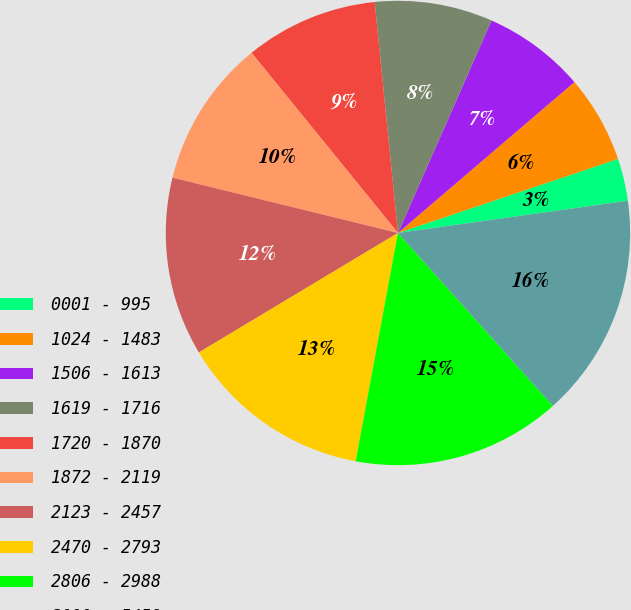<chart> <loc_0><loc_0><loc_500><loc_500><pie_chart><fcel>0001 - 995<fcel>1024 - 1483<fcel>1506 - 1613<fcel>1619 - 1716<fcel>1720 - 1870<fcel>1872 - 2119<fcel>2123 - 2457<fcel>2470 - 2793<fcel>2806 - 2988<fcel>3000 - 5458<nl><fcel>2.95%<fcel>6.09%<fcel>7.14%<fcel>8.2%<fcel>9.26%<fcel>10.31%<fcel>12.43%<fcel>13.48%<fcel>14.54%<fcel>15.59%<nl></chart> 